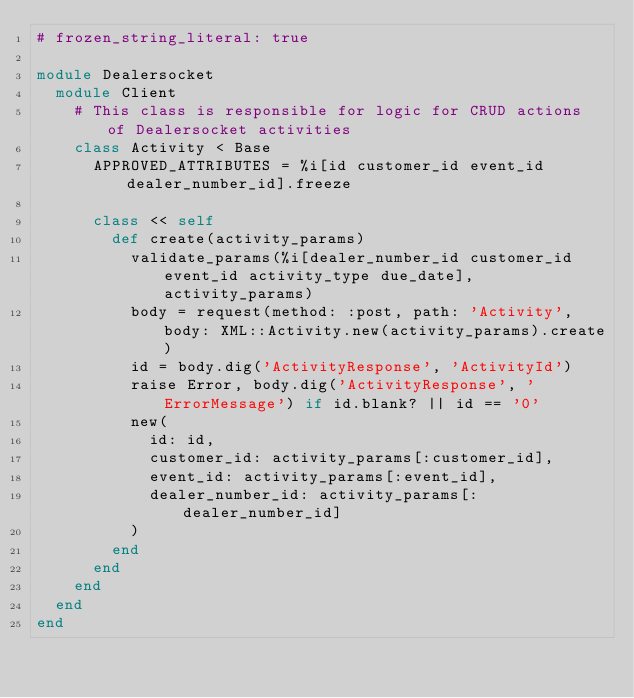Convert code to text. <code><loc_0><loc_0><loc_500><loc_500><_Ruby_># frozen_string_literal: true

module Dealersocket
  module Client
    # This class is responsible for logic for CRUD actions of Dealersocket activities
    class Activity < Base
      APPROVED_ATTRIBUTES = %i[id customer_id event_id dealer_number_id].freeze

      class << self
        def create(activity_params)
          validate_params(%i[dealer_number_id customer_id event_id activity_type due_date], activity_params)
          body = request(method: :post, path: 'Activity', body: XML::Activity.new(activity_params).create)
          id = body.dig('ActivityResponse', 'ActivityId')
          raise Error, body.dig('ActivityResponse', 'ErrorMessage') if id.blank? || id == '0'
          new(
            id: id,
            customer_id: activity_params[:customer_id],
            event_id: activity_params[:event_id],
            dealer_number_id: activity_params[:dealer_number_id]
          )
        end
      end
    end
  end
end
</code> 